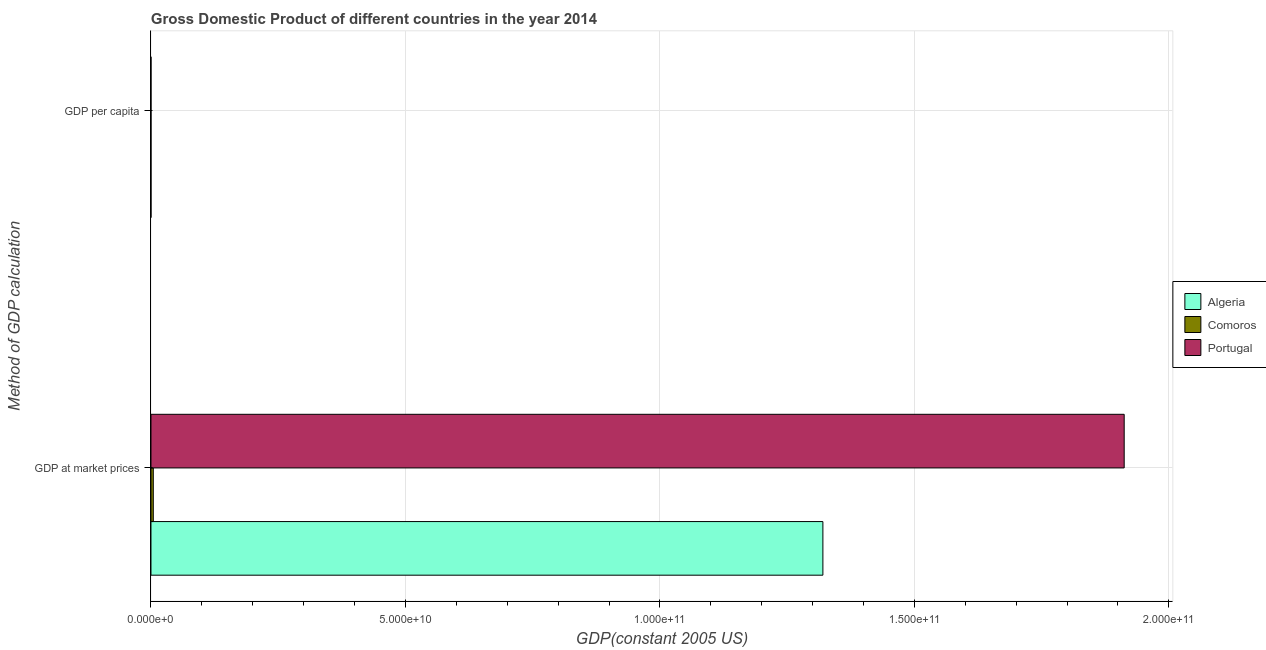How many groups of bars are there?
Keep it short and to the point. 2. Are the number of bars per tick equal to the number of legend labels?
Keep it short and to the point. Yes. How many bars are there on the 1st tick from the top?
Your answer should be compact. 3. What is the label of the 2nd group of bars from the top?
Your response must be concise. GDP at market prices. What is the gdp at market prices in Comoros?
Your answer should be very brief. 4.60e+08. Across all countries, what is the maximum gdp per capita?
Offer a very short reply. 1.84e+04. Across all countries, what is the minimum gdp per capita?
Provide a succinct answer. 596.89. In which country was the gdp at market prices maximum?
Offer a very short reply. Portugal. In which country was the gdp at market prices minimum?
Ensure brevity in your answer.  Comoros. What is the total gdp per capita in the graph?
Provide a short and direct response. 2.24e+04. What is the difference between the gdp at market prices in Portugal and that in Comoros?
Provide a succinct answer. 1.91e+11. What is the difference between the gdp per capita in Portugal and the gdp at market prices in Comoros?
Offer a terse response. -4.60e+08. What is the average gdp at market prices per country?
Your response must be concise. 1.08e+11. What is the difference between the gdp at market prices and gdp per capita in Portugal?
Your answer should be compact. 1.91e+11. In how many countries, is the gdp at market prices greater than 50000000000 US$?
Give a very brief answer. 2. What is the ratio of the gdp per capita in Comoros to that in Algeria?
Offer a terse response. 0.18. Is the gdp per capita in Algeria less than that in Portugal?
Your answer should be very brief. Yes. What does the 2nd bar from the top in GDP at market prices represents?
Offer a very short reply. Comoros. What does the 1st bar from the bottom in GDP per capita represents?
Your answer should be very brief. Algeria. How many bars are there?
Ensure brevity in your answer.  6. Are all the bars in the graph horizontal?
Your answer should be very brief. Yes. Does the graph contain grids?
Ensure brevity in your answer.  Yes. Where does the legend appear in the graph?
Give a very brief answer. Center right. How are the legend labels stacked?
Your response must be concise. Vertical. What is the title of the graph?
Ensure brevity in your answer.  Gross Domestic Product of different countries in the year 2014. Does "Burundi" appear as one of the legend labels in the graph?
Provide a short and direct response. No. What is the label or title of the X-axis?
Provide a succinct answer. GDP(constant 2005 US). What is the label or title of the Y-axis?
Provide a succinct answer. Method of GDP calculation. What is the GDP(constant 2005 US) of Algeria in GDP at market prices?
Offer a terse response. 1.32e+11. What is the GDP(constant 2005 US) of Comoros in GDP at market prices?
Keep it short and to the point. 4.60e+08. What is the GDP(constant 2005 US) of Portugal in GDP at market prices?
Keep it short and to the point. 1.91e+11. What is the GDP(constant 2005 US) in Algeria in GDP per capita?
Ensure brevity in your answer.  3390.93. What is the GDP(constant 2005 US) in Comoros in GDP per capita?
Keep it short and to the point. 596.89. What is the GDP(constant 2005 US) in Portugal in GDP per capita?
Your answer should be compact. 1.84e+04. Across all Method of GDP calculation, what is the maximum GDP(constant 2005 US) in Algeria?
Provide a succinct answer. 1.32e+11. Across all Method of GDP calculation, what is the maximum GDP(constant 2005 US) of Comoros?
Your answer should be compact. 4.60e+08. Across all Method of GDP calculation, what is the maximum GDP(constant 2005 US) of Portugal?
Provide a short and direct response. 1.91e+11. Across all Method of GDP calculation, what is the minimum GDP(constant 2005 US) of Algeria?
Your response must be concise. 3390.93. Across all Method of GDP calculation, what is the minimum GDP(constant 2005 US) in Comoros?
Your response must be concise. 596.89. Across all Method of GDP calculation, what is the minimum GDP(constant 2005 US) in Portugal?
Your response must be concise. 1.84e+04. What is the total GDP(constant 2005 US) of Algeria in the graph?
Keep it short and to the point. 1.32e+11. What is the total GDP(constant 2005 US) of Comoros in the graph?
Provide a succinct answer. 4.60e+08. What is the total GDP(constant 2005 US) of Portugal in the graph?
Ensure brevity in your answer.  1.91e+11. What is the difference between the GDP(constant 2005 US) in Algeria in GDP at market prices and that in GDP per capita?
Your answer should be compact. 1.32e+11. What is the difference between the GDP(constant 2005 US) in Comoros in GDP at market prices and that in GDP per capita?
Make the answer very short. 4.60e+08. What is the difference between the GDP(constant 2005 US) in Portugal in GDP at market prices and that in GDP per capita?
Provide a short and direct response. 1.91e+11. What is the difference between the GDP(constant 2005 US) of Algeria in GDP at market prices and the GDP(constant 2005 US) of Comoros in GDP per capita?
Offer a very short reply. 1.32e+11. What is the difference between the GDP(constant 2005 US) in Algeria in GDP at market prices and the GDP(constant 2005 US) in Portugal in GDP per capita?
Provide a short and direct response. 1.32e+11. What is the difference between the GDP(constant 2005 US) in Comoros in GDP at market prices and the GDP(constant 2005 US) in Portugal in GDP per capita?
Ensure brevity in your answer.  4.60e+08. What is the average GDP(constant 2005 US) of Algeria per Method of GDP calculation?
Make the answer very short. 6.60e+1. What is the average GDP(constant 2005 US) in Comoros per Method of GDP calculation?
Your answer should be very brief. 2.30e+08. What is the average GDP(constant 2005 US) in Portugal per Method of GDP calculation?
Your answer should be compact. 9.56e+1. What is the difference between the GDP(constant 2005 US) in Algeria and GDP(constant 2005 US) in Comoros in GDP at market prices?
Provide a short and direct response. 1.32e+11. What is the difference between the GDP(constant 2005 US) of Algeria and GDP(constant 2005 US) of Portugal in GDP at market prices?
Your answer should be compact. -5.92e+1. What is the difference between the GDP(constant 2005 US) of Comoros and GDP(constant 2005 US) of Portugal in GDP at market prices?
Give a very brief answer. -1.91e+11. What is the difference between the GDP(constant 2005 US) of Algeria and GDP(constant 2005 US) of Comoros in GDP per capita?
Offer a very short reply. 2794.05. What is the difference between the GDP(constant 2005 US) of Algeria and GDP(constant 2005 US) of Portugal in GDP per capita?
Offer a very short reply. -1.50e+04. What is the difference between the GDP(constant 2005 US) of Comoros and GDP(constant 2005 US) of Portugal in GDP per capita?
Provide a short and direct response. -1.78e+04. What is the ratio of the GDP(constant 2005 US) of Algeria in GDP at market prices to that in GDP per capita?
Ensure brevity in your answer.  3.89e+07. What is the ratio of the GDP(constant 2005 US) in Comoros in GDP at market prices to that in GDP per capita?
Your answer should be compact. 7.70e+05. What is the ratio of the GDP(constant 2005 US) of Portugal in GDP at market prices to that in GDP per capita?
Provide a short and direct response. 1.04e+07. What is the difference between the highest and the second highest GDP(constant 2005 US) in Algeria?
Provide a succinct answer. 1.32e+11. What is the difference between the highest and the second highest GDP(constant 2005 US) in Comoros?
Offer a very short reply. 4.60e+08. What is the difference between the highest and the second highest GDP(constant 2005 US) in Portugal?
Offer a very short reply. 1.91e+11. What is the difference between the highest and the lowest GDP(constant 2005 US) in Algeria?
Make the answer very short. 1.32e+11. What is the difference between the highest and the lowest GDP(constant 2005 US) of Comoros?
Give a very brief answer. 4.60e+08. What is the difference between the highest and the lowest GDP(constant 2005 US) of Portugal?
Your answer should be very brief. 1.91e+11. 